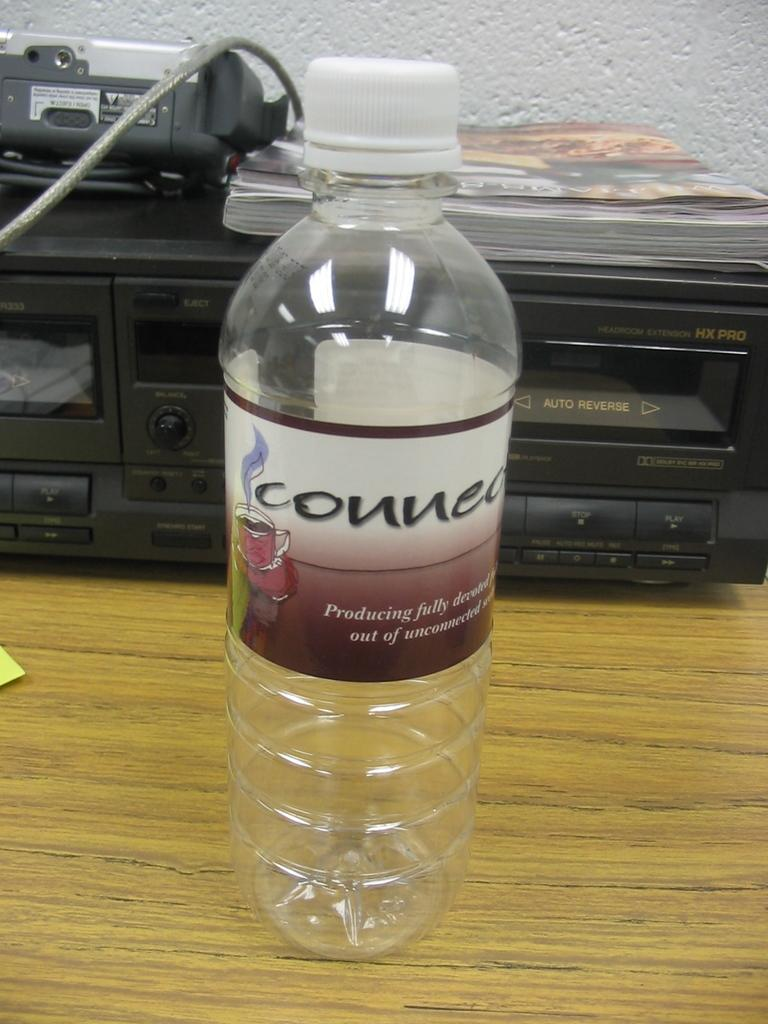What is on the table in the image? There is an empty water bottle and a black box on the table. What is on top of the black box? Notebooks are present on top of the black box. What type of truck is parked next to the table in the image? There is no truck present in the image; it only shows an empty water bottle, a black box, and notebooks on a table. 